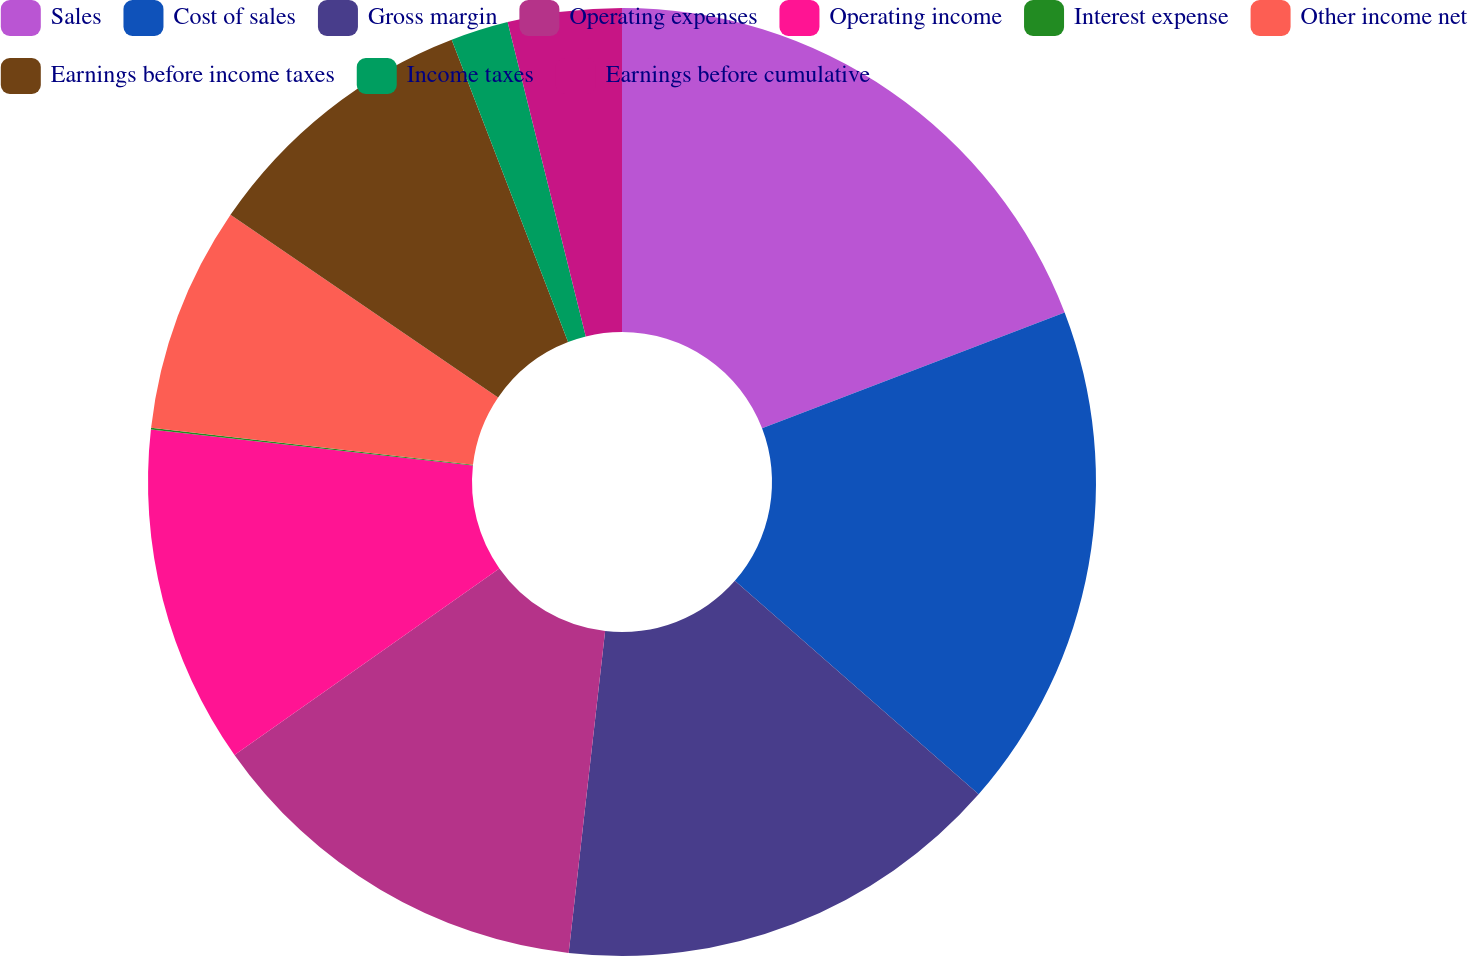<chart> <loc_0><loc_0><loc_500><loc_500><pie_chart><fcel>Sales<fcel>Cost of sales<fcel>Gross margin<fcel>Operating expenses<fcel>Operating income<fcel>Interest expense<fcel>Other income net<fcel>Earnings before income taxes<fcel>Income taxes<fcel>Earnings before cumulative<nl><fcel>19.18%<fcel>17.27%<fcel>15.35%<fcel>13.44%<fcel>11.53%<fcel>0.06%<fcel>7.71%<fcel>9.62%<fcel>1.97%<fcel>3.88%<nl></chart> 